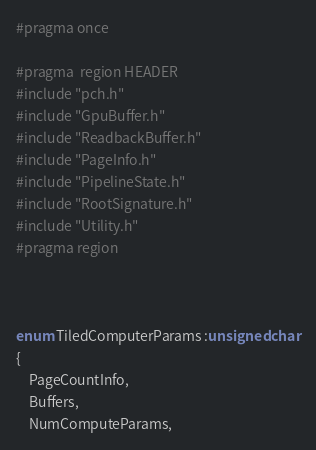Convert code to text. <code><loc_0><loc_0><loc_500><loc_500><_C_>
#pragma once

#pragma  region HEADER
#include "pch.h"
#include "GpuBuffer.h"
#include "ReadbackBuffer.h"
#include "PageInfo.h"
#include "PipelineState.h"
#include "RootSignature.h"
#include "Utility.h"
#pragma region 



enum TiledComputerParams :unsigned char
{
    PageCountInfo,
    Buffers,
    NumComputeParams,</code> 